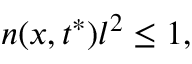Convert formula to latex. <formula><loc_0><loc_0><loc_500><loc_500>n ( x , t ^ { * } ) l ^ { 2 } \leq 1 ,</formula> 